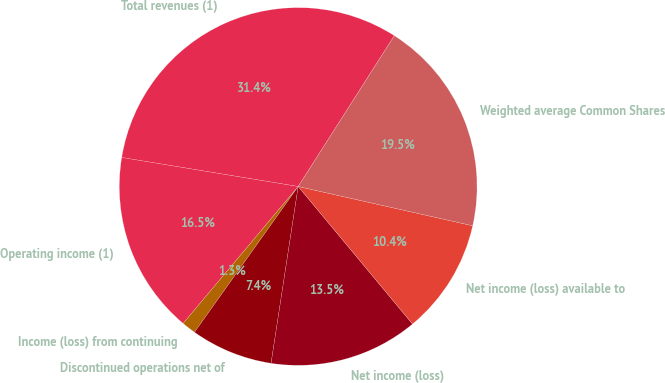Convert chart. <chart><loc_0><loc_0><loc_500><loc_500><pie_chart><fcel>Total revenues (1)<fcel>Operating income (1)<fcel>Income (loss) from continuing<fcel>Discontinued operations net of<fcel>Net income (loss)<fcel>Net income (loss) available to<fcel>Weighted average Common Shares<nl><fcel>31.44%<fcel>16.47%<fcel>1.28%<fcel>7.42%<fcel>13.46%<fcel>10.44%<fcel>19.49%<nl></chart> 